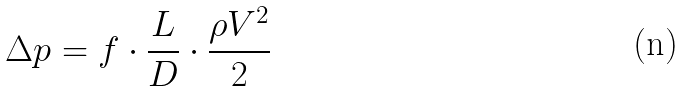Convert formula to latex. <formula><loc_0><loc_0><loc_500><loc_500>\Delta p = f \cdot \frac { L } { D } \cdot \frac { \rho V ^ { 2 } } { 2 }</formula> 